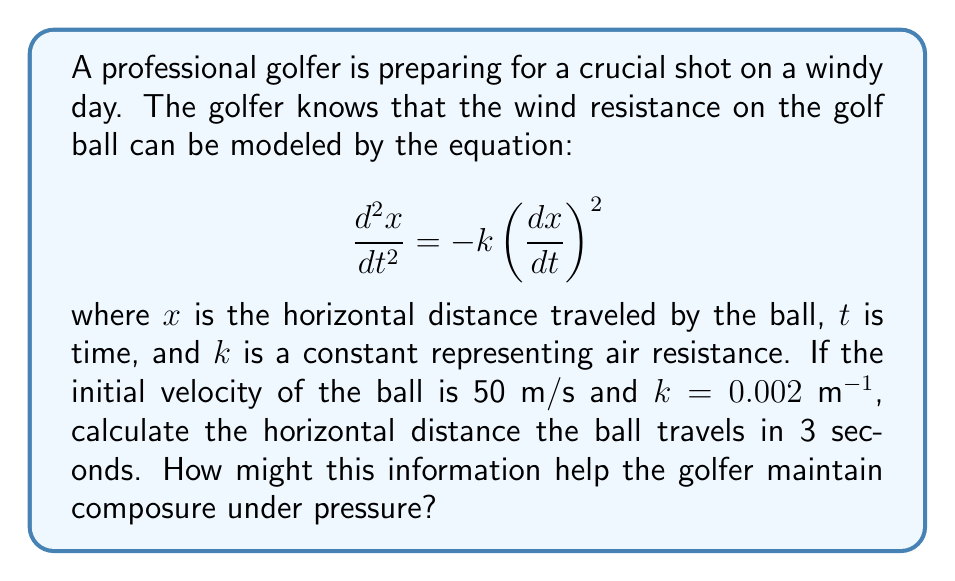Teach me how to tackle this problem. Let's approach this step-by-step:

1) First, we need to solve the differential equation. Let $v = \frac{dx}{dt}$, then the equation becomes:

   $$\frac{dv}{dt} = -kv^2$$

2) This can be solved by separation of variables:

   $$\int \frac{dv}{v^2} = -k \int dt$$

3) Integrating both sides:

   $$-\frac{1}{v} = -kt + C$$

4) Using the initial condition $v(0) = 50$ m/s, we can find C:

   $$-\frac{1}{50} = C$$

   So, $$-\frac{1}{v} = -kt - \frac{1}{50}$$

5) Solving for v:

   $$v = \frac{50}{1 + 50kt}$$

6) Now, we need to integrate v to find x:

   $$x = \int v dt = \int \frac{50}{1 + 50kt} dt$$

7) This integral results in:

   $$x = \frac{1}{k} \ln(1 + 50kt)$$

8) Now, we can plug in our values: $k = 0.002$ m^-1, $t = 3$ s

   $$x = \frac{1}{0.002} \ln(1 + 50 \cdot 0.002 \cdot 3)$$

9) Calculating:

   $$x = 500 \ln(1.3) \approx 131.03 \text{ meters}$$

This information can help the golfer maintain composure under pressure by providing a precise expectation of the ball's behavior. Knowing the exact distance the ball will travel allows for more confident decision-making, potentially reducing anxiety and improving performance.
Answer: 131.03 meters 